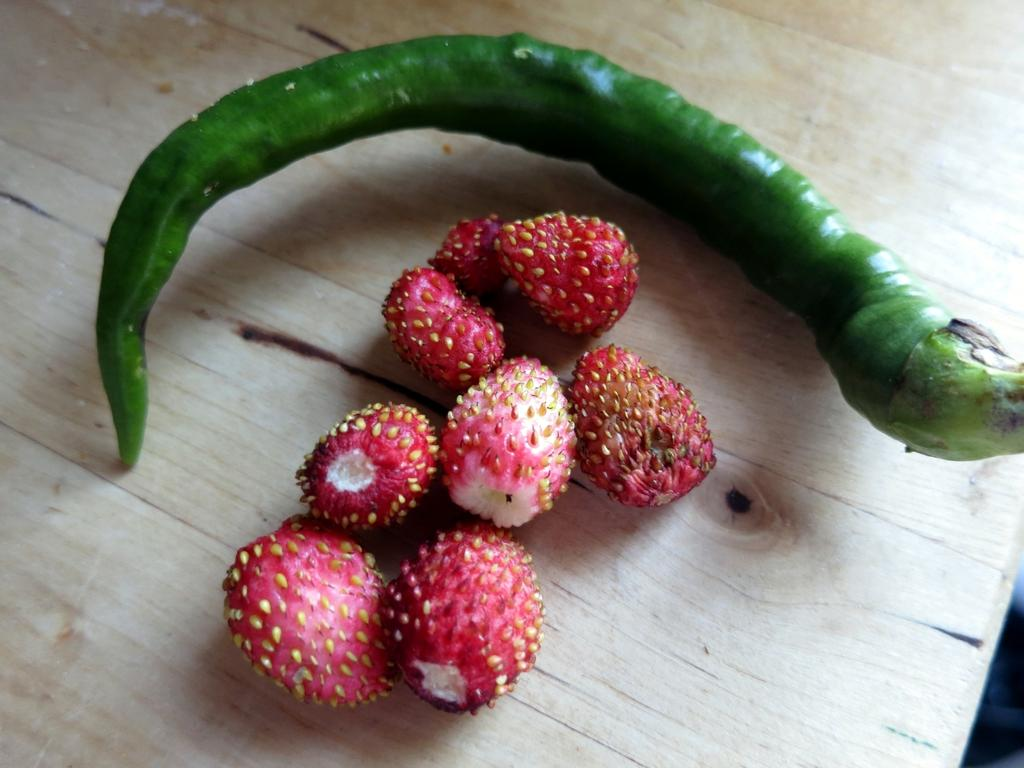What type of fruit can be seen in the image? There are strawberries in the image. What other type of food is present in the image? There is a green chilli in the image. On what surface are the strawberries and green chilli placed? The objects are placed on a wooden surface. What type of territory is being claimed by the pigs in the image? There are no pigs present in the image, so no territory is being claimed. Can you tell me how many strings are on the guitar in the image? There is no guitar present in the image. 